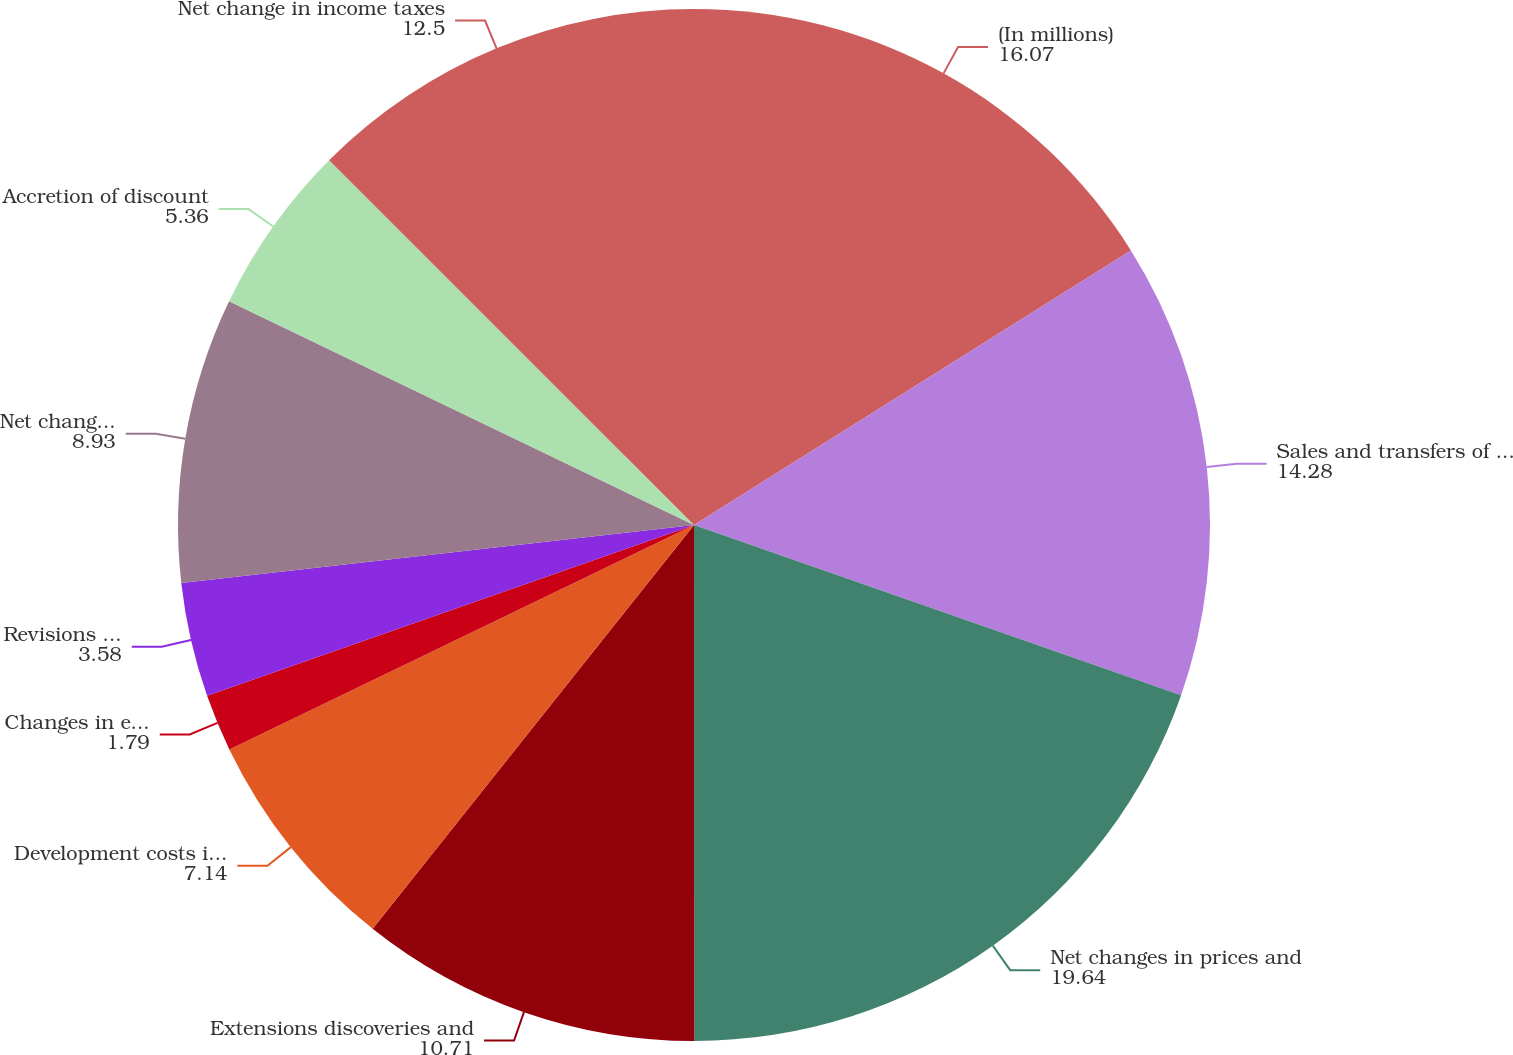Convert chart to OTSL. <chart><loc_0><loc_0><loc_500><loc_500><pie_chart><fcel>(In millions)<fcel>Sales and transfers of oil and<fcel>Net changes in prices and<fcel>Extensions discoveries and<fcel>Development costs incurred<fcel>Changes in estimated future<fcel>Revisions of previous quantity<fcel>Net changes in purchases and<fcel>Accretion of discount<fcel>Net change in income taxes<nl><fcel>16.07%<fcel>14.28%<fcel>19.64%<fcel>10.71%<fcel>7.14%<fcel>1.79%<fcel>3.58%<fcel>8.93%<fcel>5.36%<fcel>12.5%<nl></chart> 